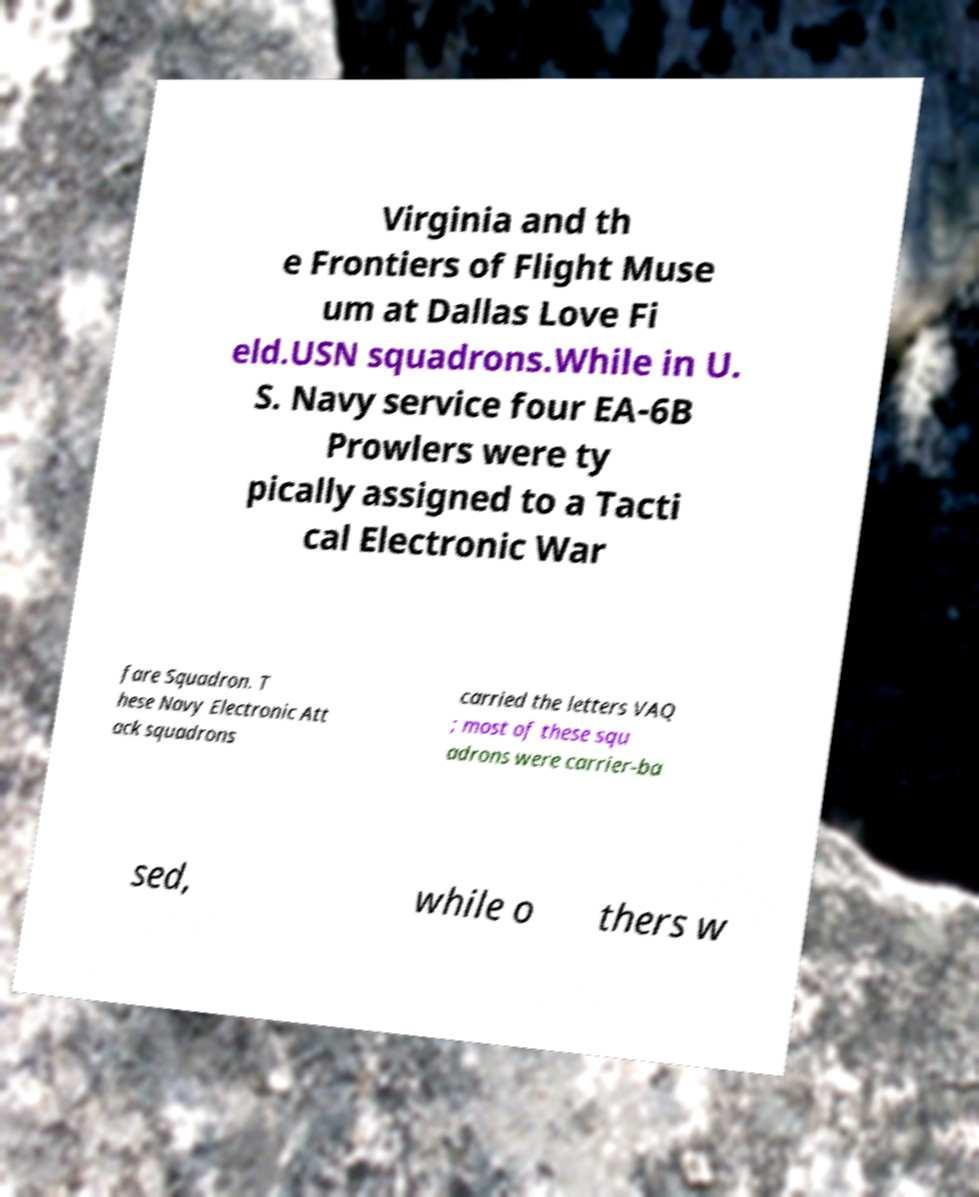For documentation purposes, I need the text within this image transcribed. Could you provide that? Virginia and th e Frontiers of Flight Muse um at Dallas Love Fi eld.USN squadrons.While in U. S. Navy service four EA-6B Prowlers were ty pically assigned to a Tacti cal Electronic War fare Squadron. T hese Navy Electronic Att ack squadrons carried the letters VAQ ; most of these squ adrons were carrier-ba sed, while o thers w 